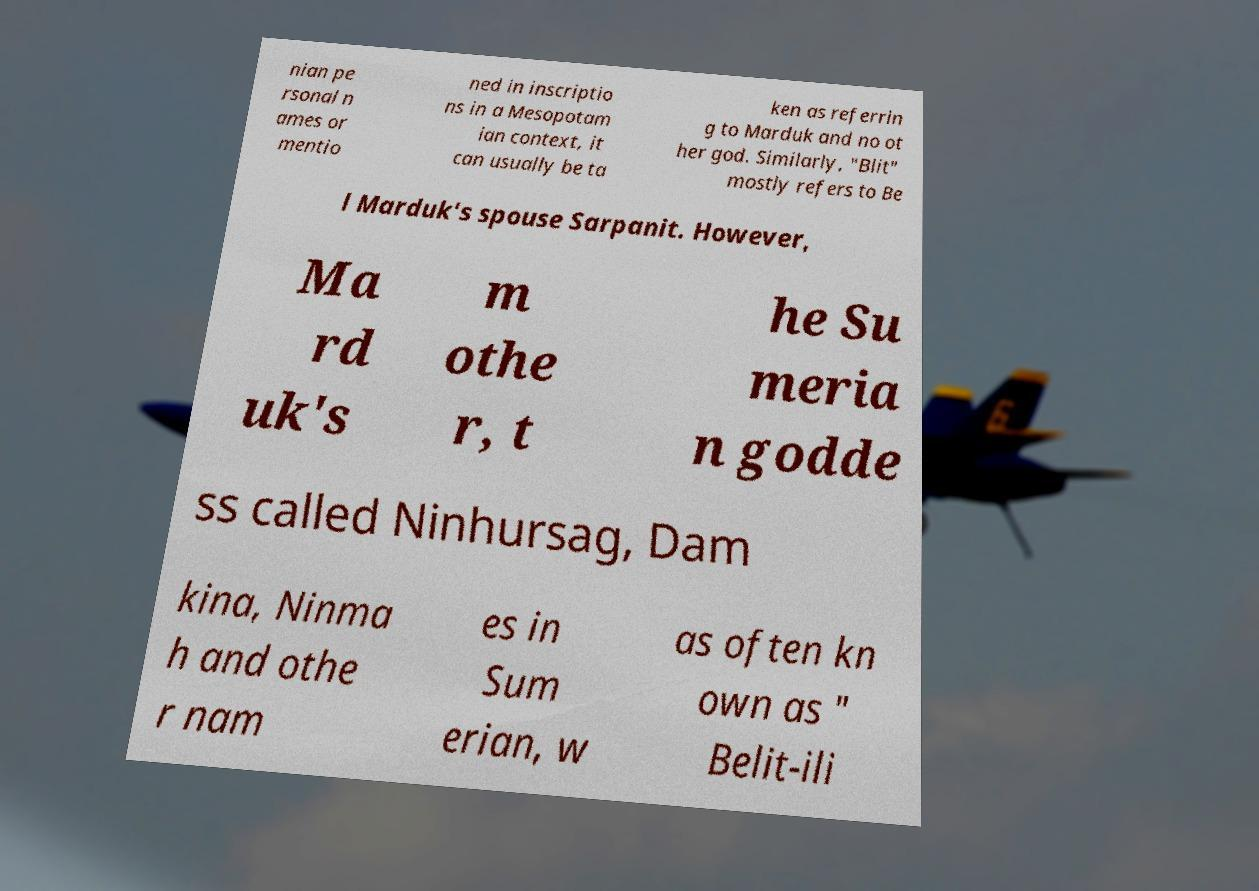Could you extract and type out the text from this image? nian pe rsonal n ames or mentio ned in inscriptio ns in a Mesopotam ian context, it can usually be ta ken as referrin g to Marduk and no ot her god. Similarly, "Blit" mostly refers to Be l Marduk's spouse Sarpanit. However, Ma rd uk's m othe r, t he Su meria n godde ss called Ninhursag, Dam kina, Ninma h and othe r nam es in Sum erian, w as often kn own as " Belit-ili 